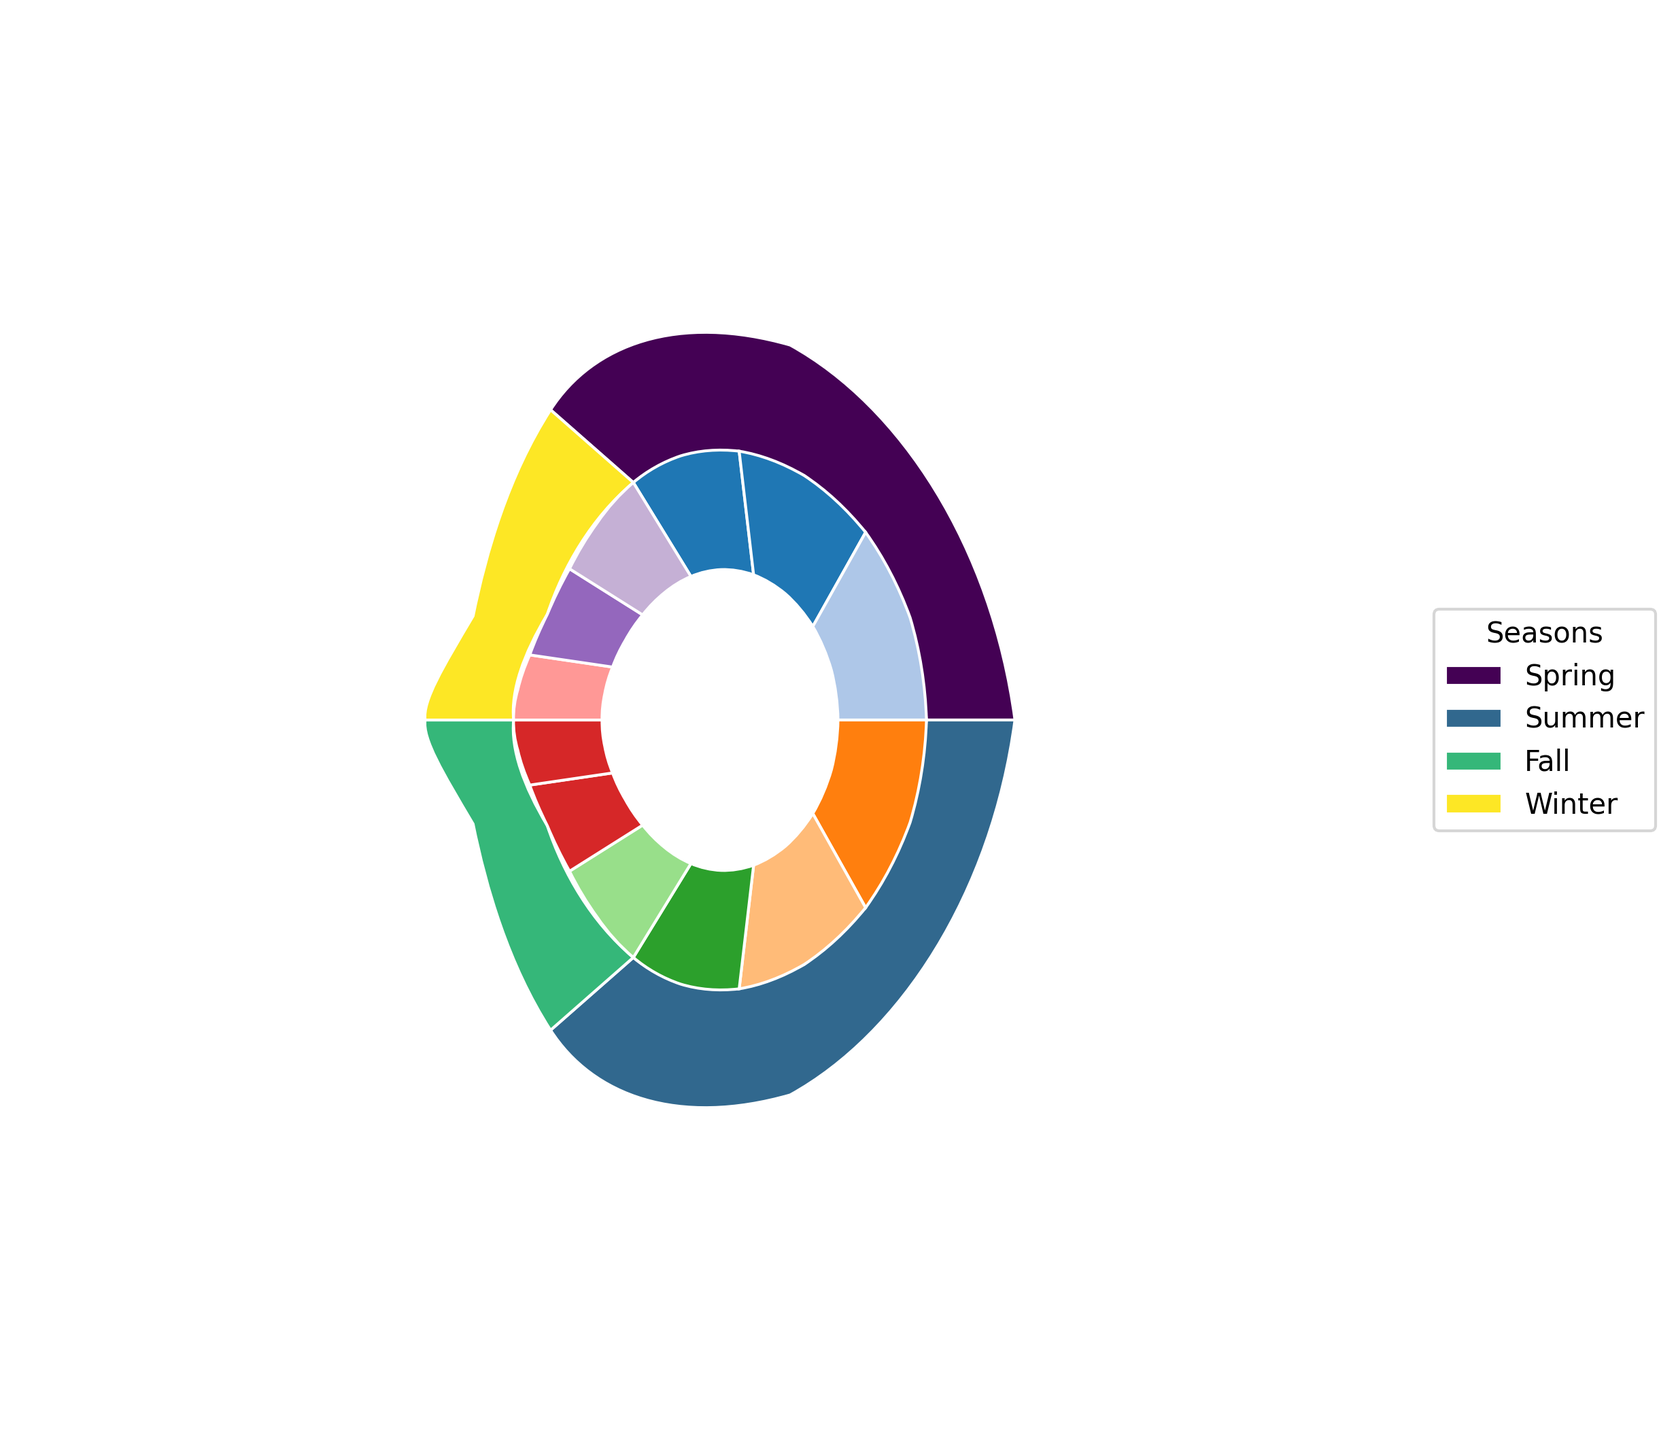What season has the highest variety of produce types? To find the season with the highest variety, we need to count the unique produce types in each season segment. Spring and Summer each have 6 types, while Fall and Winter each have 5 types. Therefore, Spring and Summer have the highest variety.
Answer: Spring and Summer Which color represents the least variety of produce types, and in which season does it appear? We need to check the segments with fewer types. Winter has the lightest shade of green and includes 4 types: Cabbage, Brussels Sprouts, Winter Squash, and Rutabaga. Winter represents the least variety.
Answer: Winter Between Spring and Winter, which season has more types of fruits? Spring has Strawberries and Rhubarb (2 types), while Winter has Grapefruit and Oranges (2 types). Both seasons have an equal number of fruit types.
Answer: Equal What is the total number of root vegetables available across all seasons? We need to sum up the root vegetables in each season: Spring (Radishes, Carrots = 2), Summer (Beets, New Potatoes = 2), Fall (Turnips, Parsnips = 2), Winter (Winter Squash, Rutabaga = 2). Total = 2 + 2 + 2 + 2 = 8
Answer: 8 Which season includes the most leafy greens, and what are they? By counting: Spring (Spinach, Kale), Summer (Lettuce, Collard Greens), Fall (Swiss Chard, Arugula), Winter (Cabbage, Brussels Sprouts). Each season has 2 leafy greens. Since all seasons tie, we can list any, e.g., Spring has Spinach and Kale.
Answer: Spring: Spinach, Kale How many more fruit types are available in Summer compared to Winter? Summer has Blueberries and Watermelon (2 types), and Winter has Grapefruit and Oranges (2 types). Therefore, there is no difference.
Answer: 0 Which season has the darkest shade of color, and what types of produce does it include? A visual inspection shows that the darkest segment represents Fall. The types of produce are: Swiss Chard, Arugula (Leafy Greens); Turnips, Parsnips (Root Vegetables); Apples, Cranberries.
Answer: Fall: Swiss Chard, Arugula, Turnips, Parsnips, Apples, Cranberries If we group all the seasons by the type of produce, which type is most consistently available throughout the year? We need to check each type: Leafy Greens (Spinach, Kale, Lettuce, Collard Greens, Swiss Chard, Arugula, Cabbage, Brussels Sprouts), Root Vegetables (Radishes, Carrots, Beets, New Potatoes, Turnips, Parsnips, Winter Squash, Rutabaga), Fruits (Strawberries, Rhubarb, Blueberries, Watermelon, Apples, Cranberries, Grapefruit, Oranges). Leafy Greens and Root Vegetables are both consistently available.
Answer: Leafy Greens and Root Vegetables 